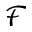<formula> <loc_0><loc_0><loc_500><loc_500>\mathcal { F }</formula> 